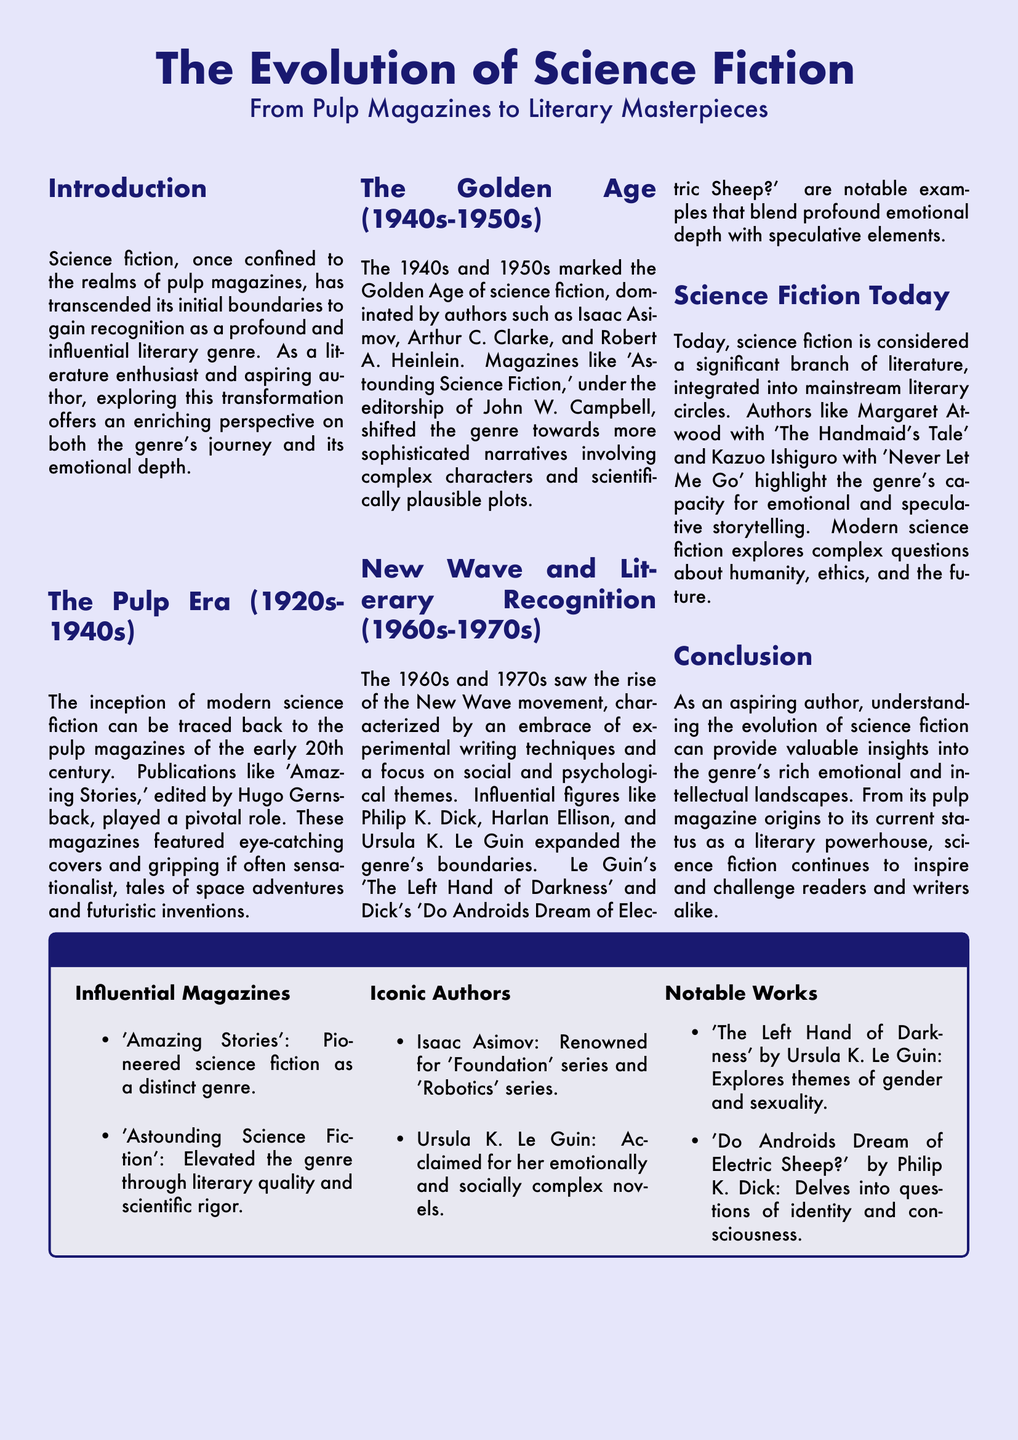What is the title of the magazine layout? The title is prominently displayed at the top of the document, indicating the subject it covers.
Answer: The Evolution of Science Fiction Who edited 'Amazing Stories'? The document specifies that Hugo Gernsback played a pivotal role in the publication of this magazine.
Answer: Hugo Gernsback What significant movement is discussed for the years 1960s-1970s? This term describes a shift in narrative style and thematic focus within science fiction literature during this era.
Answer: New Wave Which author is celebrated for the 'Foundation' series? The document highlights this author's contributions to the genre, associating them with a notable series.
Answer: Isaac Asimov What are two notable works mentioned in the highlights section? The highlight box lists specific literary works that are key to the evolution of science fiction as mentioned in the document.
Answer: The Left Hand of Darkness, Do Androids Dream of Electric Sheep? What decade marks the Golden Age of Science Fiction? The document states that this specific time frame is critical in the development of science fiction literature.
Answer: 1940s-1950s How is modern science fiction described in terms of its literary status? This information reflects on the acceptance and integration of the genre into broader literary discussions today.
Answer: Significant branch of literature Which author is associated with 'The Handmaid's Tale'? The document attributes this work to a specific author known for their literary contributions within science fiction.
Answer: Margaret Atwood 